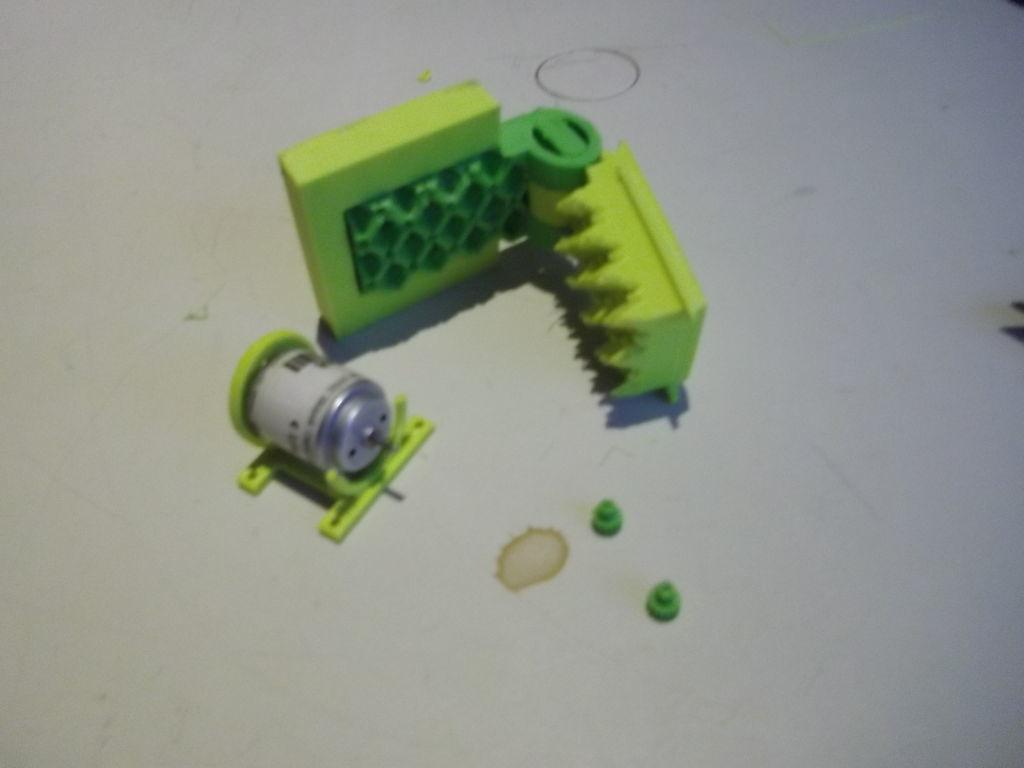Describe this image in one or two sentences. In this picture there are objects on the floor. At the bottom there is a white floor and there is a stain on the floor. 